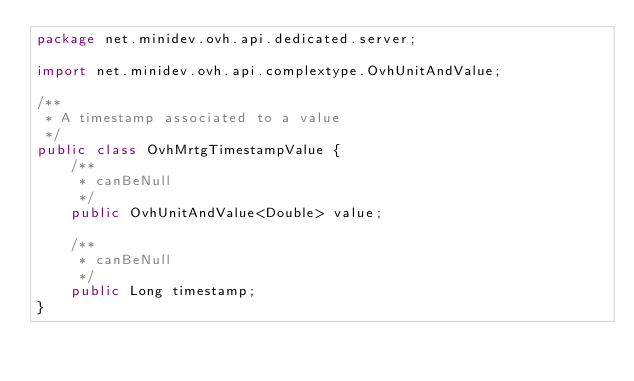<code> <loc_0><loc_0><loc_500><loc_500><_Java_>package net.minidev.ovh.api.dedicated.server;

import net.minidev.ovh.api.complextype.OvhUnitAndValue;

/**
 * A timestamp associated to a value
 */
public class OvhMrtgTimestampValue {
	/**
	 * canBeNull
	 */
	public OvhUnitAndValue<Double> value;

	/**
	 * canBeNull
	 */
	public Long timestamp;
}
</code> 